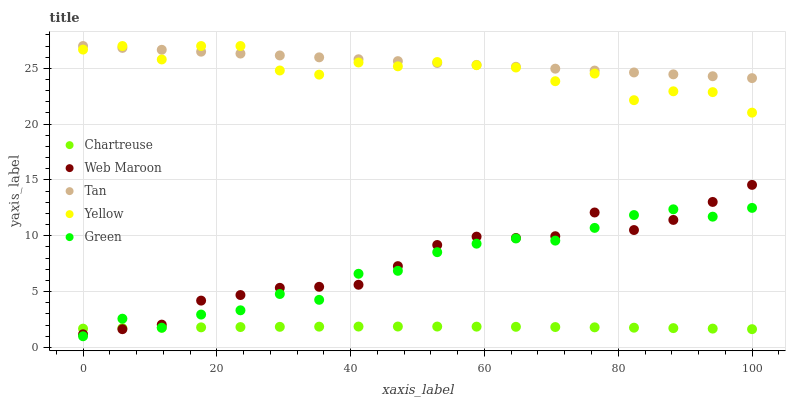Does Chartreuse have the minimum area under the curve?
Answer yes or no. Yes. Does Tan have the maximum area under the curve?
Answer yes or no. Yes. Does Web Maroon have the minimum area under the curve?
Answer yes or no. No. Does Web Maroon have the maximum area under the curve?
Answer yes or no. No. Is Tan the smoothest?
Answer yes or no. Yes. Is Yellow the roughest?
Answer yes or no. Yes. Is Chartreuse the smoothest?
Answer yes or no. No. Is Chartreuse the roughest?
Answer yes or no. No. Does Green have the lowest value?
Answer yes or no. Yes. Does Chartreuse have the lowest value?
Answer yes or no. No. Does Yellow have the highest value?
Answer yes or no. Yes. Does Web Maroon have the highest value?
Answer yes or no. No. Is Web Maroon less than Tan?
Answer yes or no. Yes. Is Yellow greater than Chartreuse?
Answer yes or no. Yes. Does Green intersect Web Maroon?
Answer yes or no. Yes. Is Green less than Web Maroon?
Answer yes or no. No. Is Green greater than Web Maroon?
Answer yes or no. No. Does Web Maroon intersect Tan?
Answer yes or no. No. 